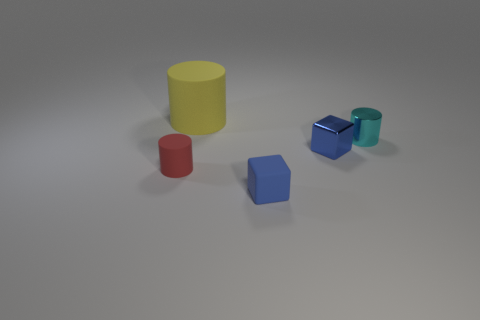Add 2 small shiny cylinders. How many objects exist? 7 Subtract all cubes. How many objects are left? 3 Subtract all blue matte blocks. Subtract all blue matte blocks. How many objects are left? 3 Add 4 big cylinders. How many big cylinders are left? 5 Add 5 large red metal balls. How many large red metal balls exist? 5 Subtract 0 purple cylinders. How many objects are left? 5 